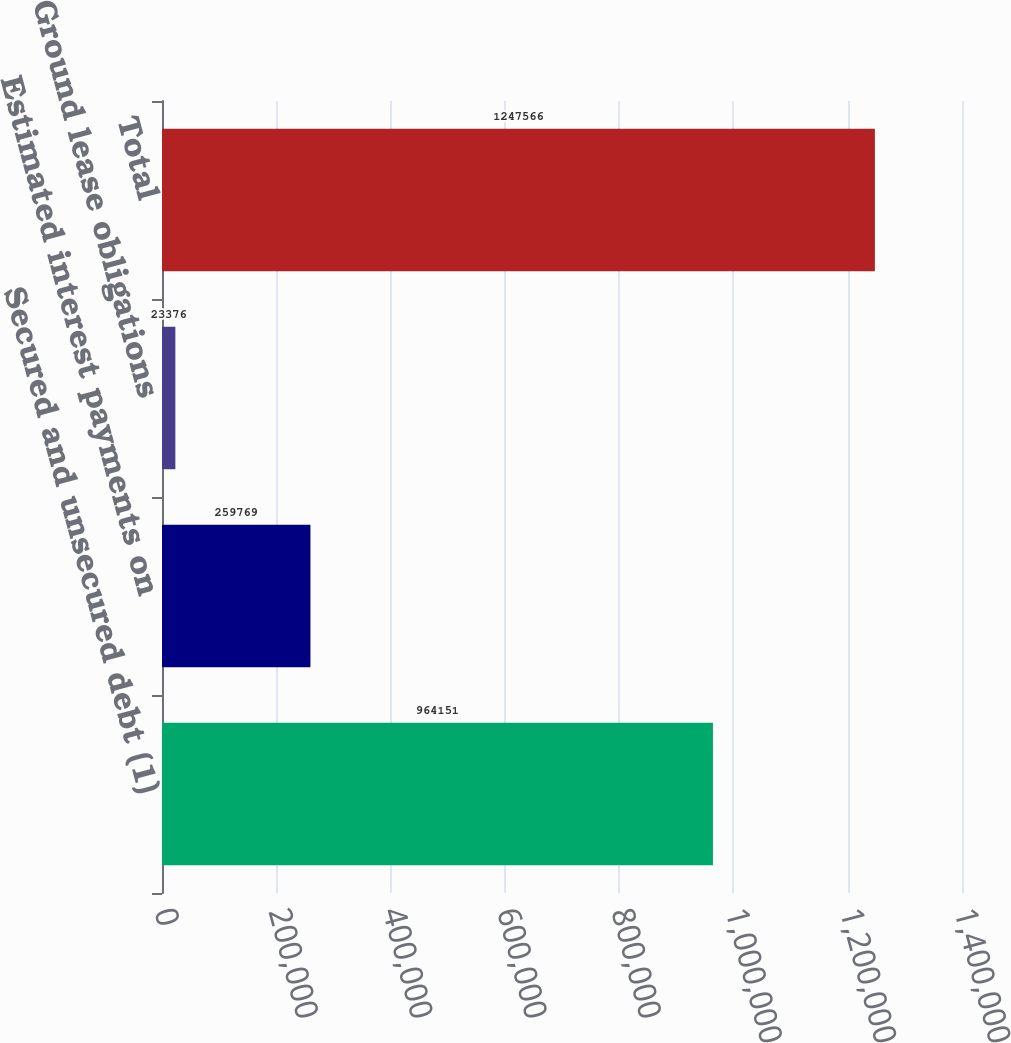Convert chart to OTSL. <chart><loc_0><loc_0><loc_500><loc_500><bar_chart><fcel>Secured and unsecured debt (1)<fcel>Estimated interest payments on<fcel>Ground lease obligations<fcel>Total<nl><fcel>964151<fcel>259769<fcel>23376<fcel>1.24757e+06<nl></chart> 